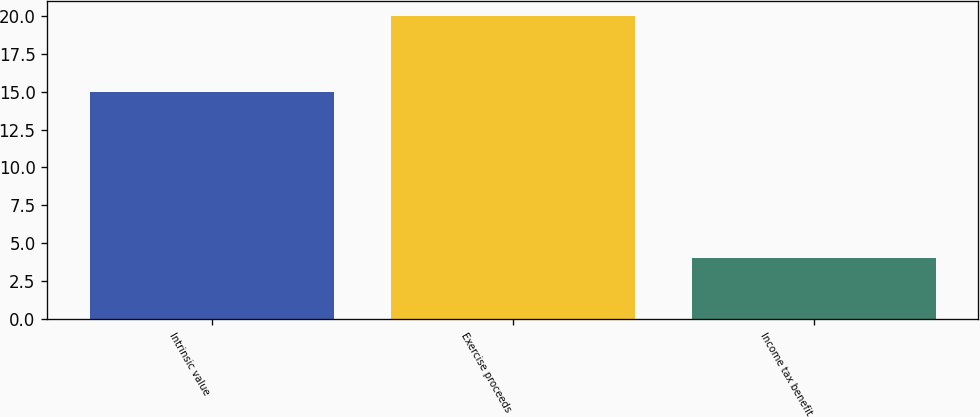Convert chart to OTSL. <chart><loc_0><loc_0><loc_500><loc_500><bar_chart><fcel>Intrinsic value<fcel>Exercise proceeds<fcel>Income tax benefit<nl><fcel>15<fcel>20<fcel>4<nl></chart> 